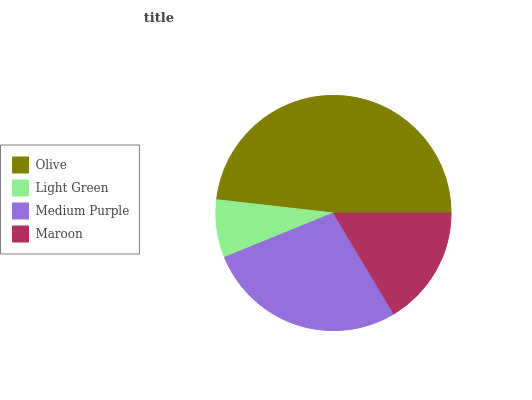Is Light Green the minimum?
Answer yes or no. Yes. Is Olive the maximum?
Answer yes or no. Yes. Is Medium Purple the minimum?
Answer yes or no. No. Is Medium Purple the maximum?
Answer yes or no. No. Is Medium Purple greater than Light Green?
Answer yes or no. Yes. Is Light Green less than Medium Purple?
Answer yes or no. Yes. Is Light Green greater than Medium Purple?
Answer yes or no. No. Is Medium Purple less than Light Green?
Answer yes or no. No. Is Medium Purple the high median?
Answer yes or no. Yes. Is Maroon the low median?
Answer yes or no. Yes. Is Light Green the high median?
Answer yes or no. No. Is Olive the low median?
Answer yes or no. No. 